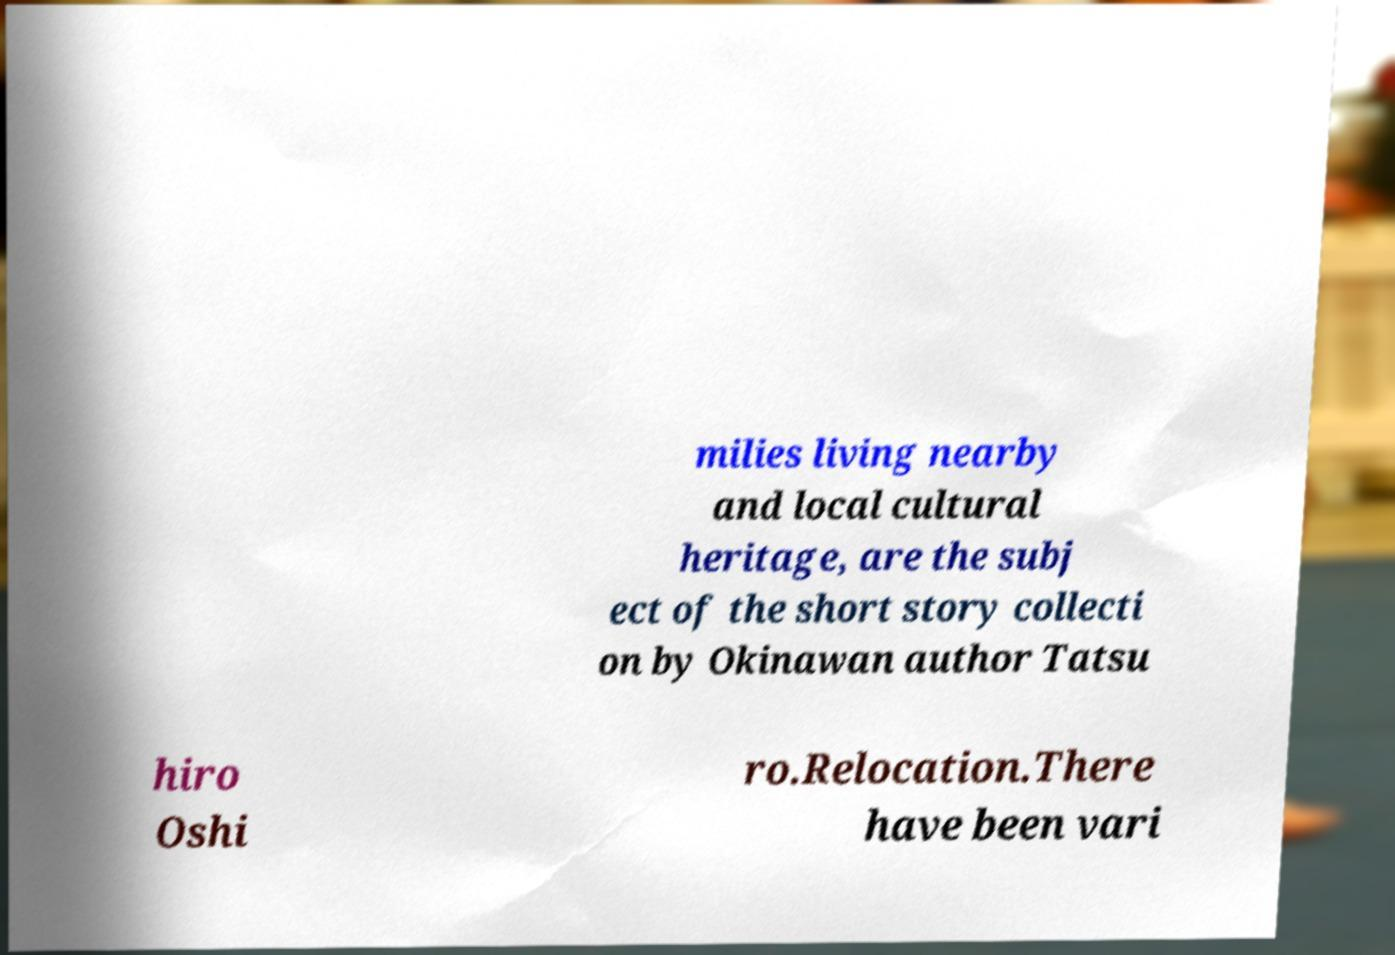Can you read and provide the text displayed in the image?This photo seems to have some interesting text. Can you extract and type it out for me? milies living nearby and local cultural heritage, are the subj ect of the short story collecti on by Okinawan author Tatsu hiro Oshi ro.Relocation.There have been vari 